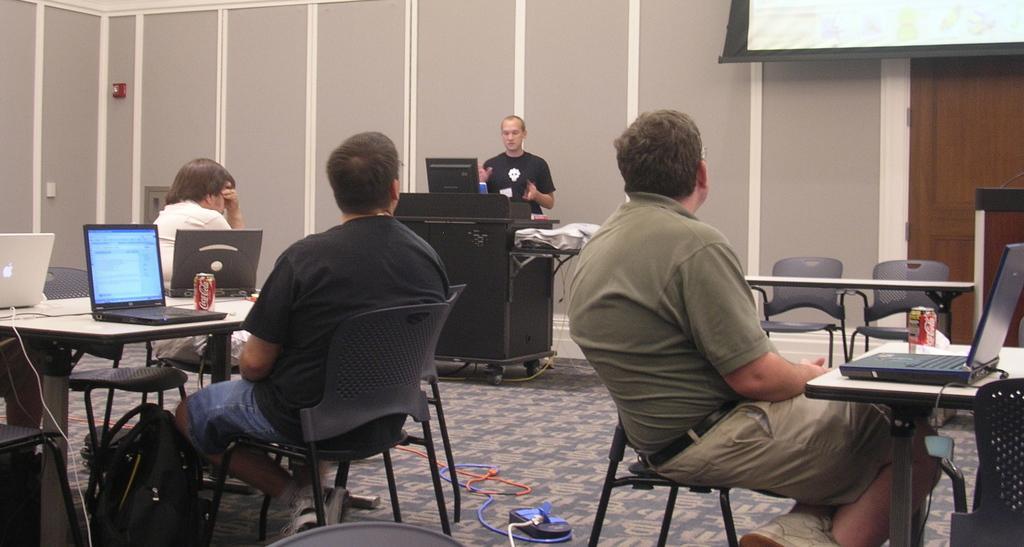How would you summarize this image in a sentence or two? Three person are sitting on chair. And there are many table. On the table there are many laptops, can, wires. On the floor there are bags, sockets, extension board. In the background there is a person standing. In front of him there is a table. On the table there is a laptop. In the background there is a wall, screen and a door. 